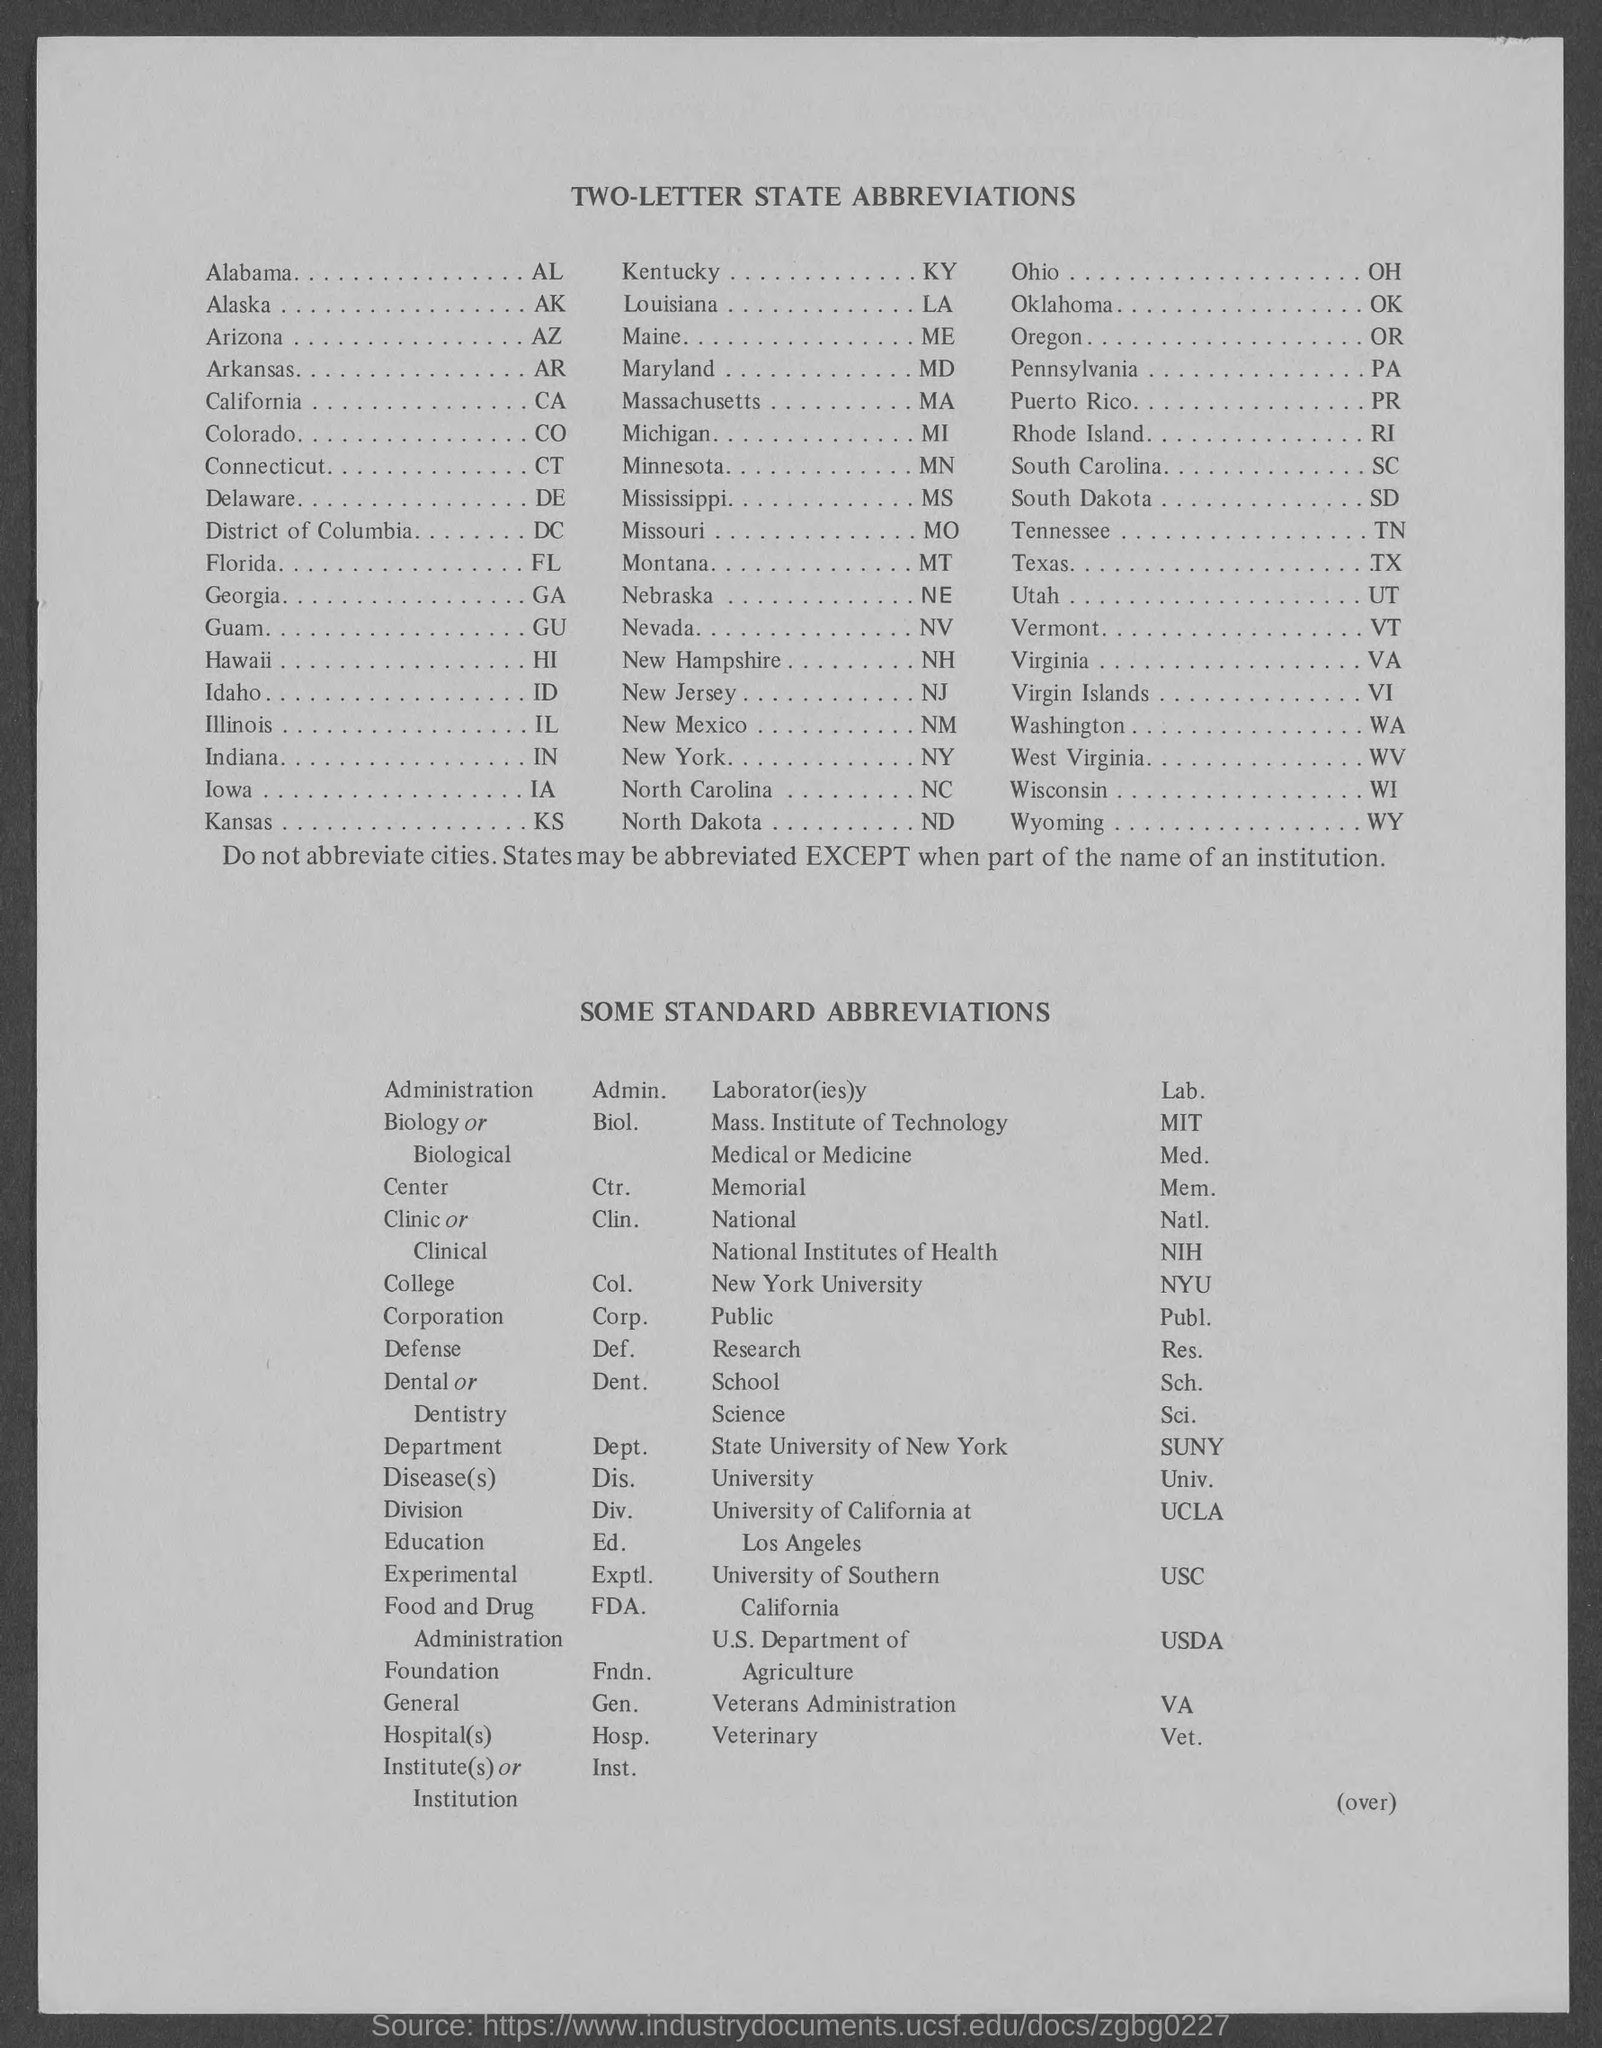What is the abbreviation for Alaska?
 AK 